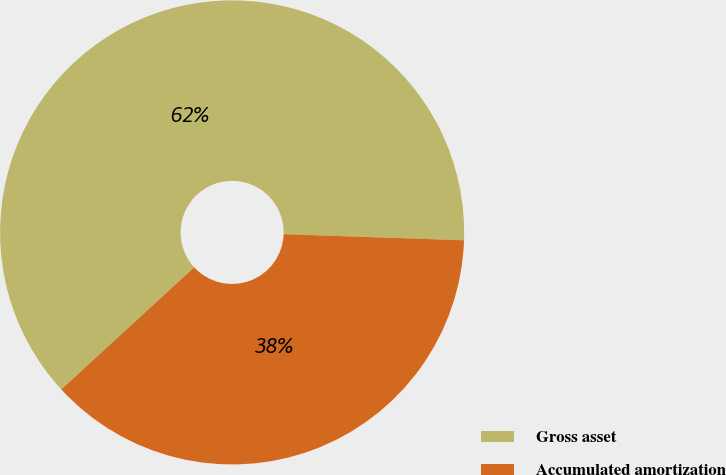<chart> <loc_0><loc_0><loc_500><loc_500><pie_chart><fcel>Gross asset<fcel>Accumulated amortization<nl><fcel>62.37%<fcel>37.63%<nl></chart> 